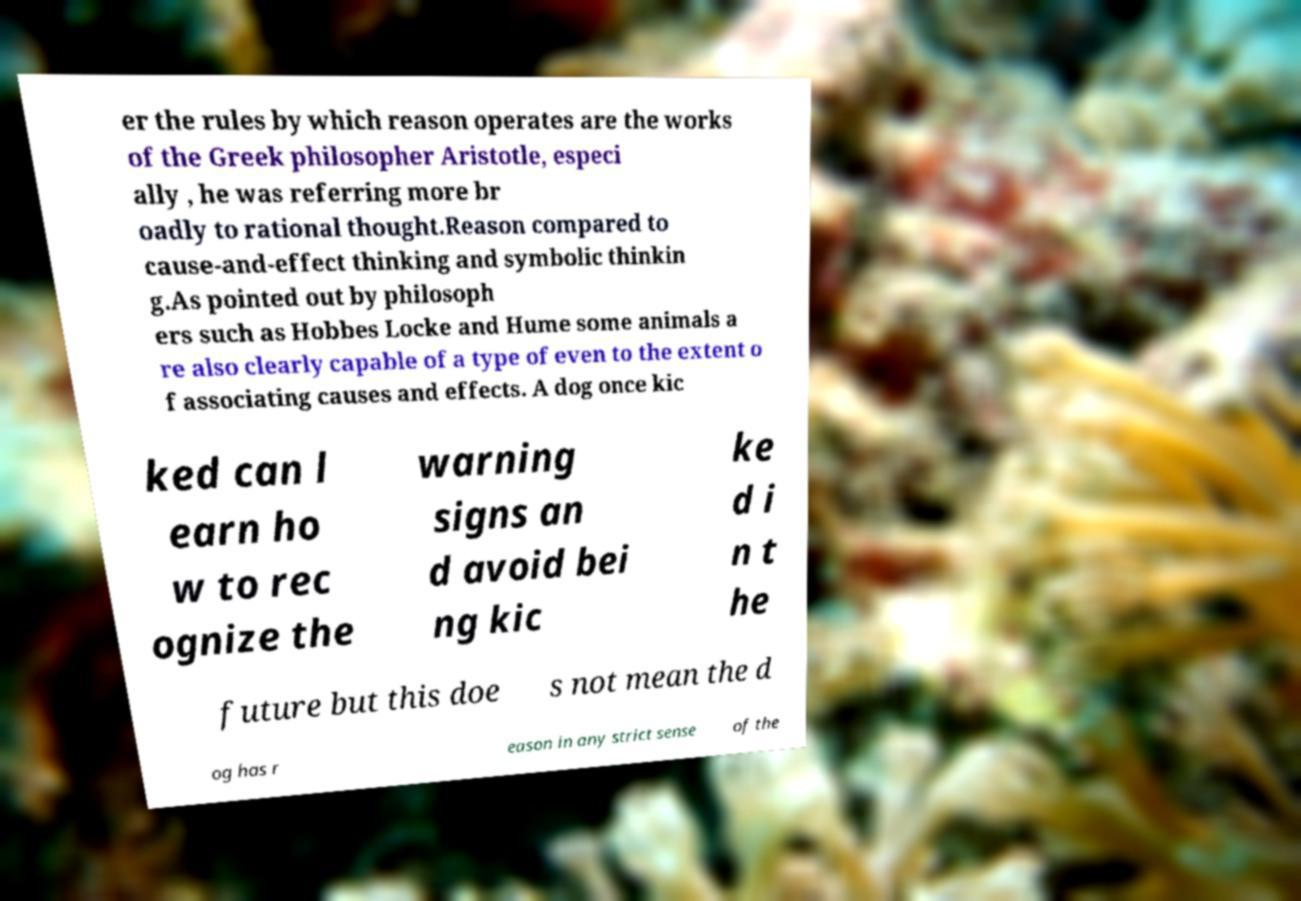What messages or text are displayed in this image? I need them in a readable, typed format. er the rules by which reason operates are the works of the Greek philosopher Aristotle, especi ally , he was referring more br oadly to rational thought.Reason compared to cause-and-effect thinking and symbolic thinkin g.As pointed out by philosoph ers such as Hobbes Locke and Hume some animals a re also clearly capable of a type of even to the extent o f associating causes and effects. A dog once kic ked can l earn ho w to rec ognize the warning signs an d avoid bei ng kic ke d i n t he future but this doe s not mean the d og has r eason in any strict sense of the 